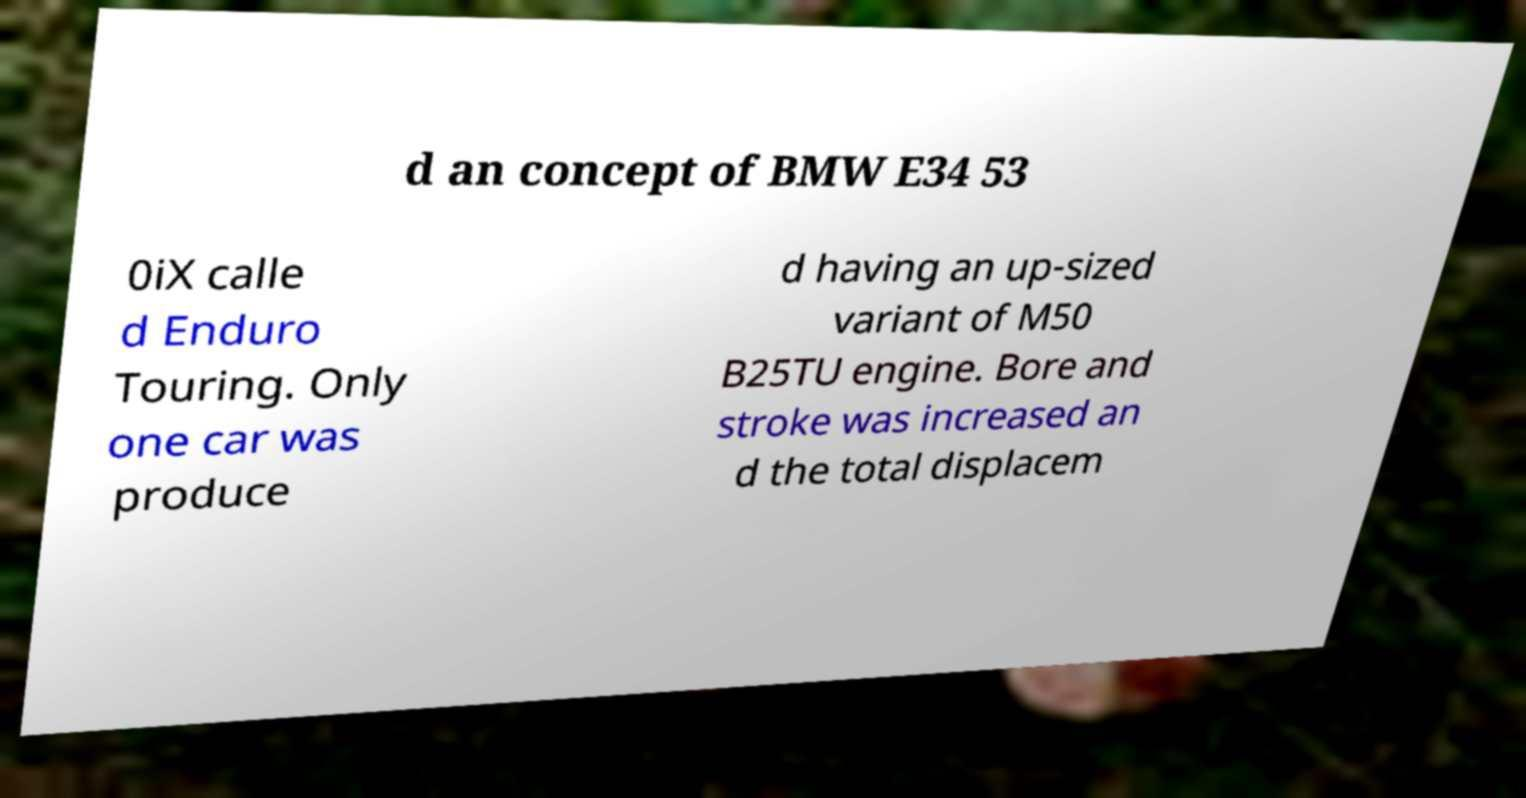Please read and relay the text visible in this image. What does it say? d an concept of BMW E34 53 0iX calle d Enduro Touring. Only one car was produce d having an up-sized variant of M50 B25TU engine. Bore and stroke was increased an d the total displacem 